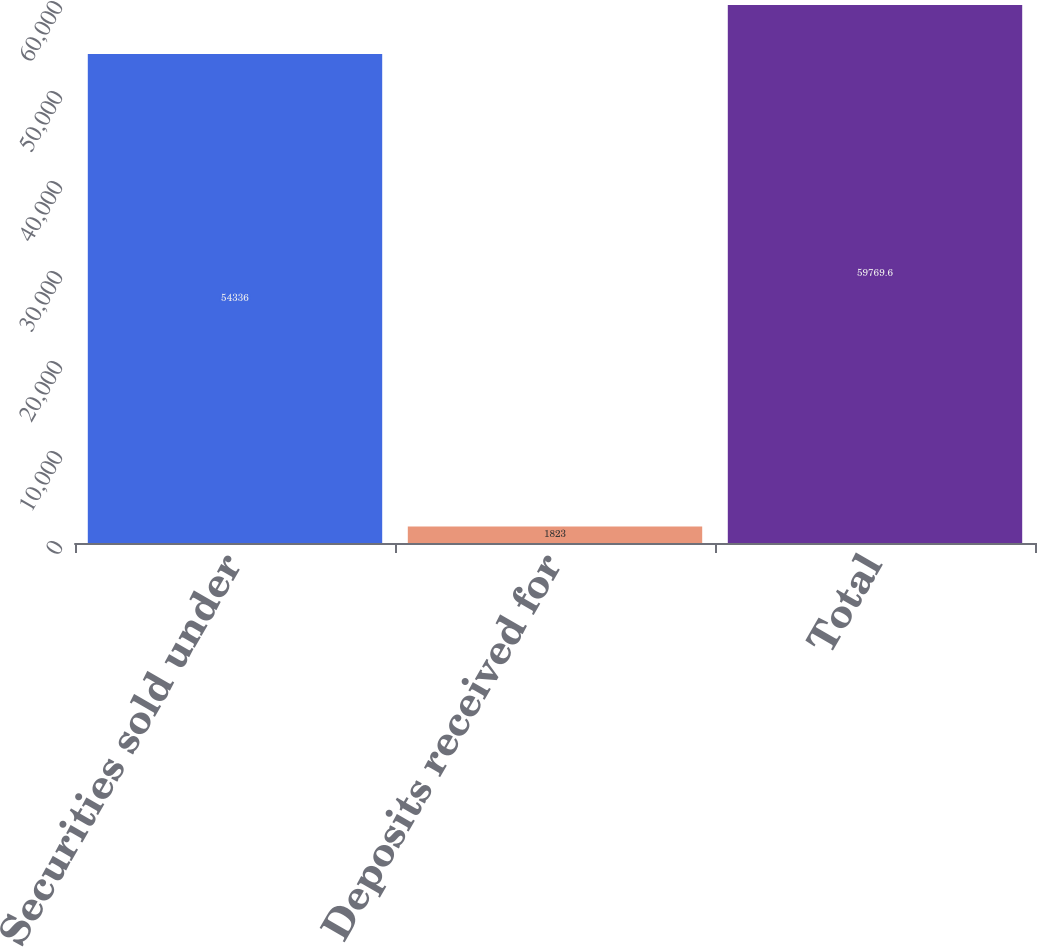Convert chart to OTSL. <chart><loc_0><loc_0><loc_500><loc_500><bar_chart><fcel>Securities sold under<fcel>Deposits received for<fcel>Total<nl><fcel>54336<fcel>1823<fcel>59769.6<nl></chart> 